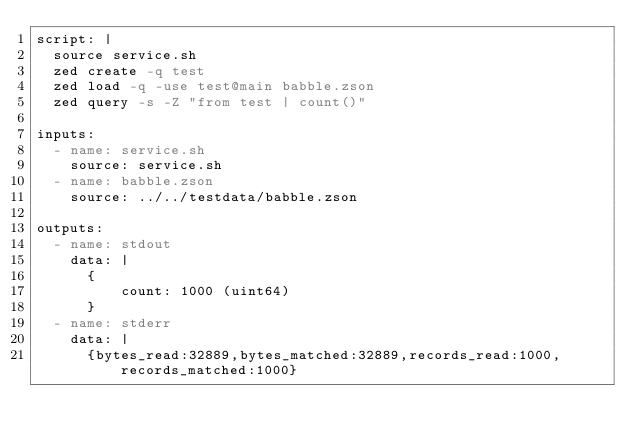Convert code to text. <code><loc_0><loc_0><loc_500><loc_500><_YAML_>script: |
  source service.sh
  zed create -q test
  zed load -q -use test@main babble.zson
  zed query -s -Z "from test | count()"

inputs:
  - name: service.sh
    source: service.sh
  - name: babble.zson
    source: ../../testdata/babble.zson

outputs:
  - name: stdout
    data: |
      {
          count: 1000 (uint64)
      }
  - name: stderr
    data: |
      {bytes_read:32889,bytes_matched:32889,records_read:1000,records_matched:1000}
</code> 